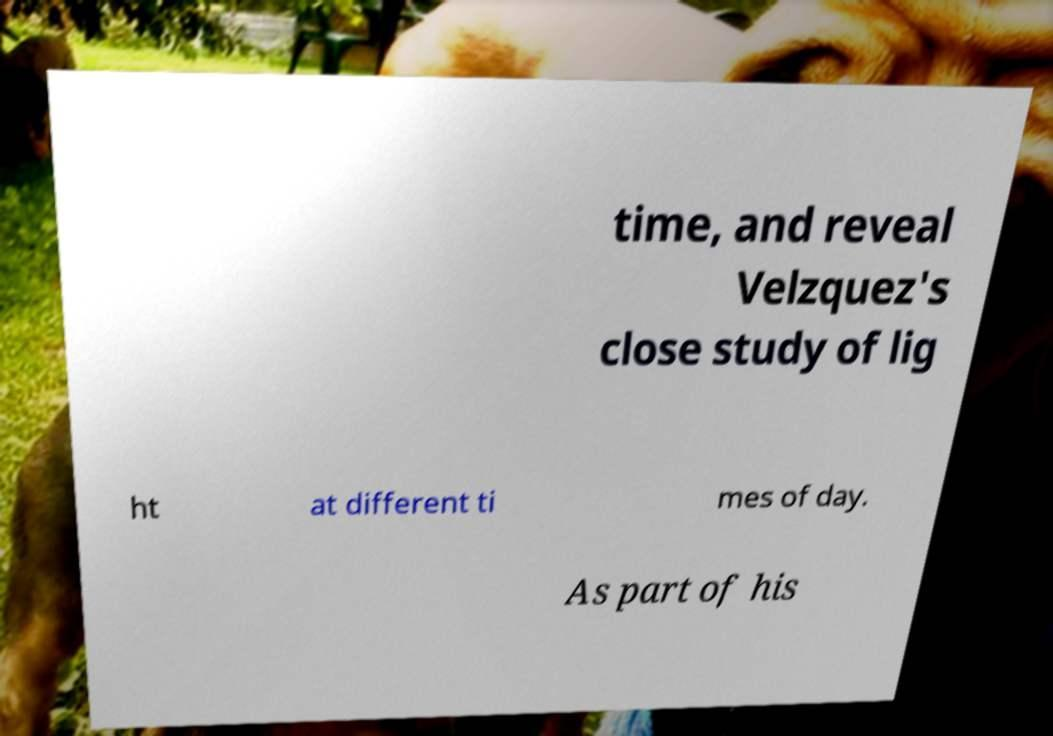Can you read and provide the text displayed in the image?This photo seems to have some interesting text. Can you extract and type it out for me? time, and reveal Velzquez's close study of lig ht at different ti mes of day. As part of his 